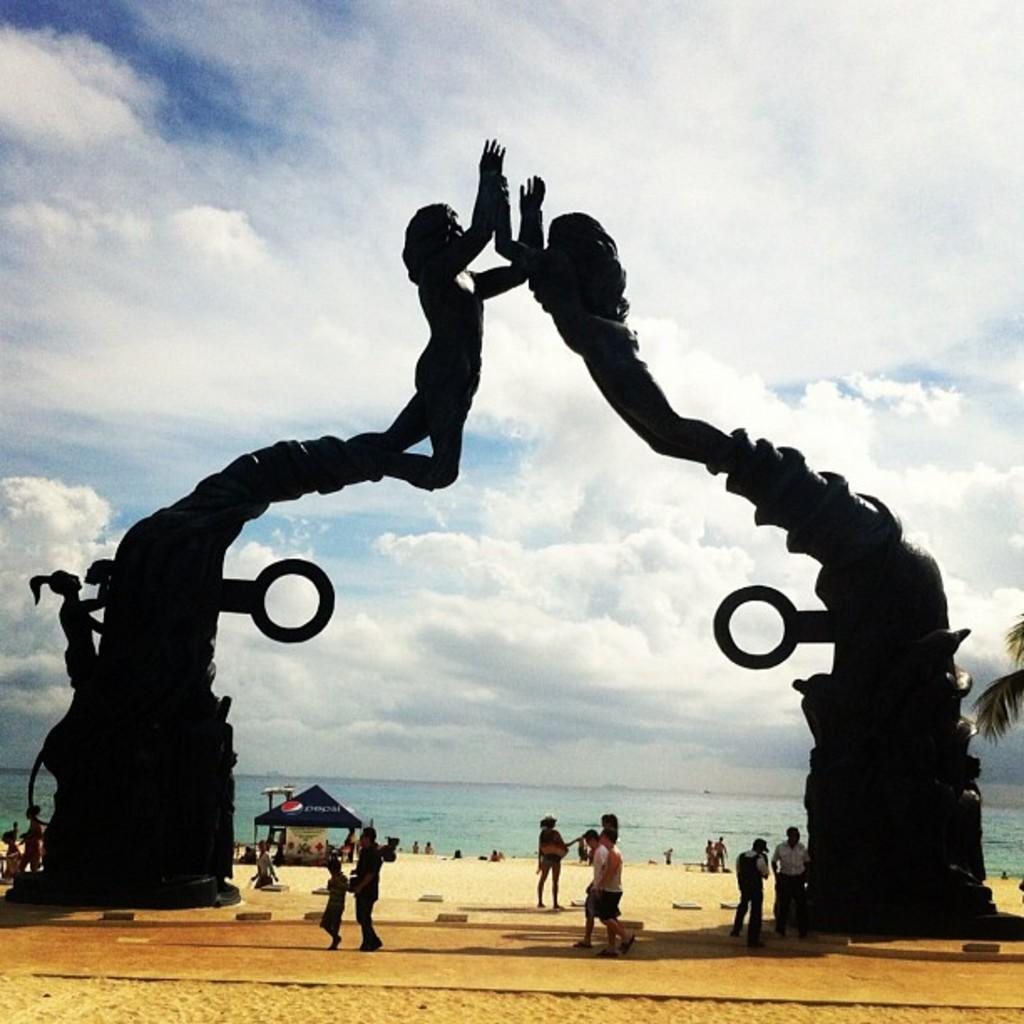How many people are in the group visible in the image? There is a group of people in the image, but the exact number is not specified. What can be seen above the group of people in the image? There is an arch with sculptures in the image. What type of shelter is present in the image? There is a canopy tent in the image. What type of vegetation is present in the image? There is a tree in the image. What natural element is visible in the image? There is water visible in the image. What is visible in the background of the image? The sky is visible in the background of the image. Who is the creator of the water visible in the image? The water in the image is a natural element and does not have a creator. What type of transport is available for the group of people in the image? The image does not show any means of transport for the group of people. 